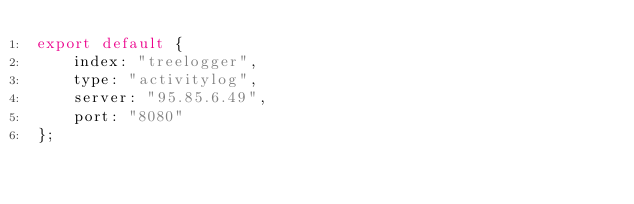<code> <loc_0><loc_0><loc_500><loc_500><_JavaScript_>export default {
	index: "treelogger",
	type: "activitylog",
	server: "95.85.6.49",
	port: "8080"
};</code> 